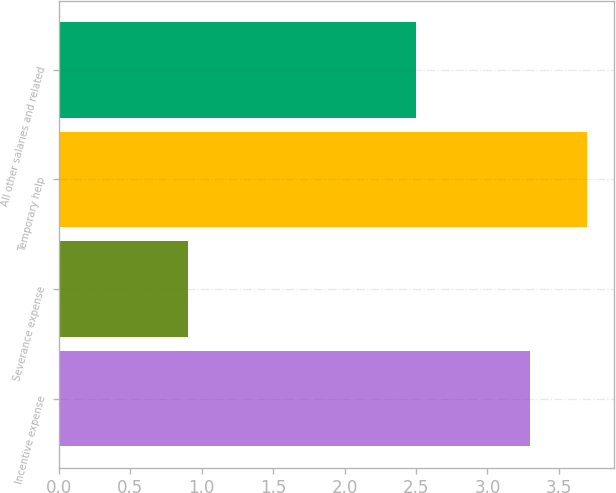Convert chart. <chart><loc_0><loc_0><loc_500><loc_500><bar_chart><fcel>Incentive expense<fcel>Severance expense<fcel>Temporary help<fcel>All other salaries and related<nl><fcel>3.3<fcel>0.9<fcel>3.7<fcel>2.5<nl></chart> 